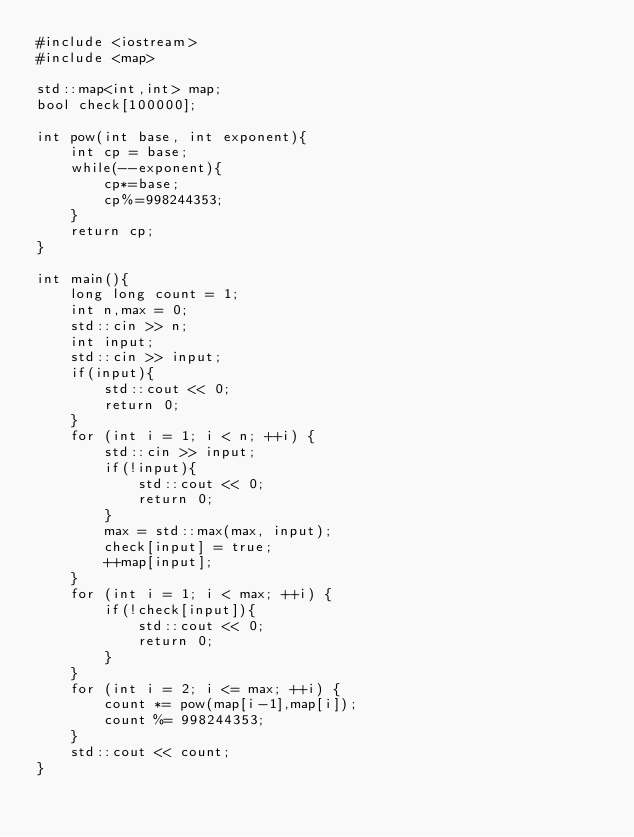<code> <loc_0><loc_0><loc_500><loc_500><_C++_>#include <iostream>
#include <map>

std::map<int,int> map;
bool check[100000];

int pow(int base, int exponent){
    int cp = base;
    while(--exponent){
        cp*=base;
        cp%=998244353;
    }
    return cp;
}

int main(){
    long long count = 1;
    int n,max = 0;
    std::cin >> n;
    int input;
    std::cin >> input;
    if(input){
        std::cout << 0;
        return 0;
    }
    for (int i = 1; i < n; ++i) {
        std::cin >> input;
        if(!input){
            std::cout << 0;
            return 0;
        }
        max = std::max(max, input);
        check[input] = true;
        ++map[input];
    }
    for (int i = 1; i < max; ++i) {
        if(!check[input]){
            std::cout << 0;
            return 0;
        }
    }
    for (int i = 2; i <= max; ++i) {
        count *= pow(map[i-1],map[i]);
        count %= 998244353;
    }
    std::cout << count;
}</code> 